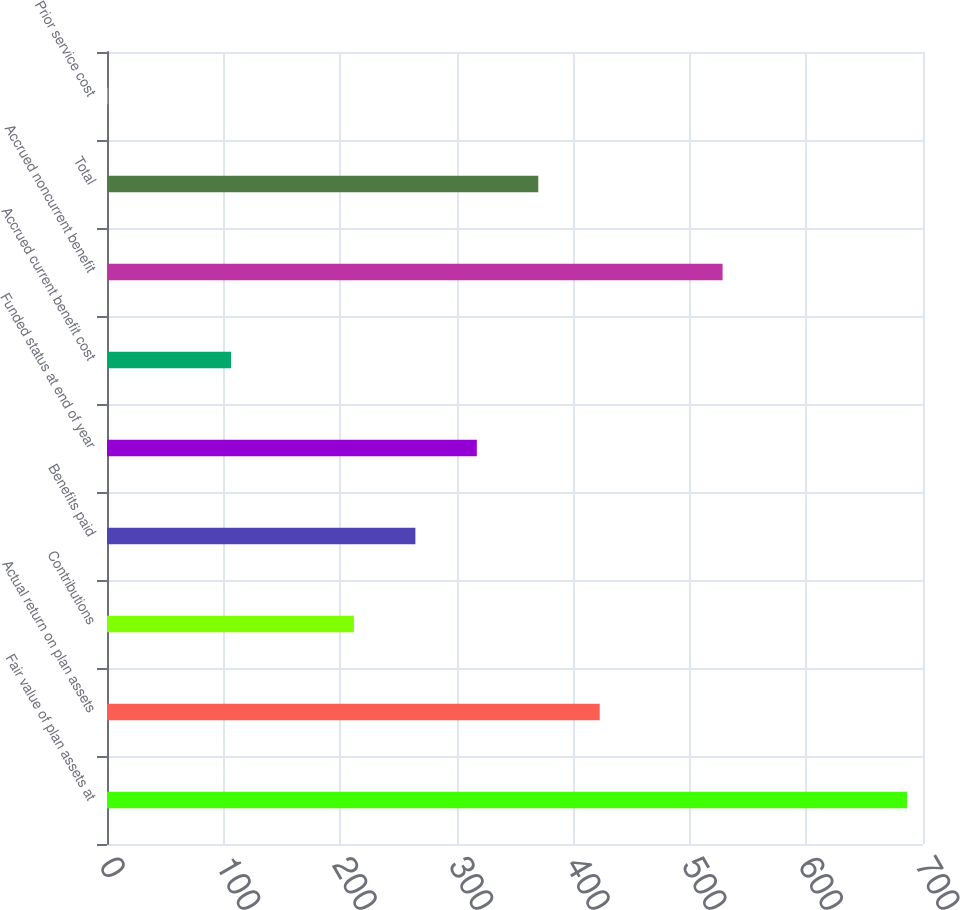<chart> <loc_0><loc_0><loc_500><loc_500><bar_chart><fcel>Fair value of plan assets at<fcel>Actual return on plan assets<fcel>Contributions<fcel>Benefits paid<fcel>Funded status at end of year<fcel>Accrued current benefit cost<fcel>Accrued noncurrent benefit<fcel>Total<fcel>Prior service cost<nl><fcel>686.23<fcel>422.68<fcel>211.84<fcel>264.55<fcel>317.26<fcel>106.42<fcel>528.1<fcel>369.97<fcel>1<nl></chart> 